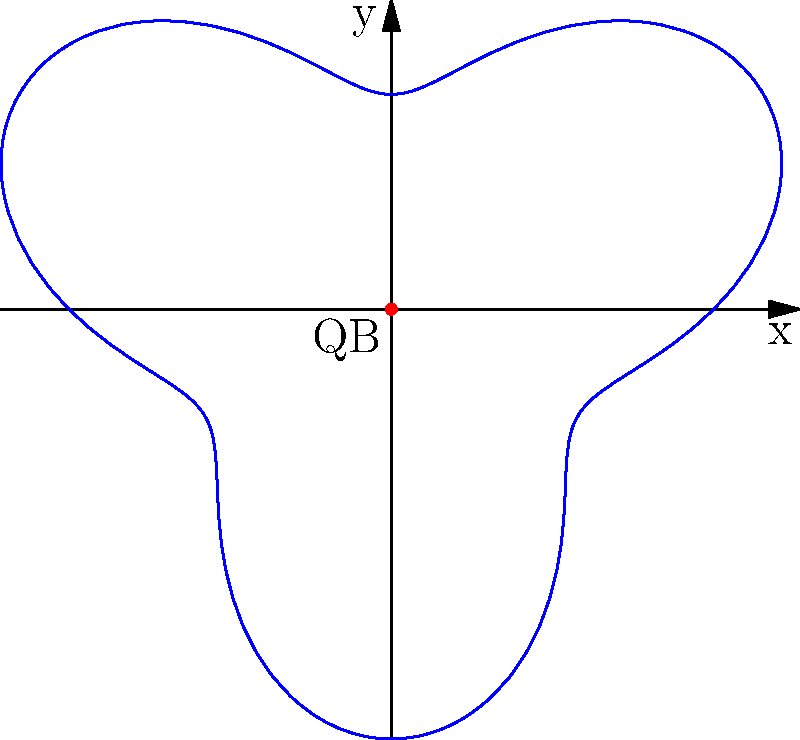As a star wide receiver, you run a complex route that can be modeled using the polar equation $r = 3 + \sin(3\theta)$, where $r$ is in yards. What is the maximum distance you reach from the quarterback (located at the origin) during this route? To find the maximum distance from the quarterback, we need to determine the maximum value of $r$ in the given polar equation.

1) The equation is $r = 3 + \sin(3\theta)$

2) The sine function always oscillates between -1 and 1.

3) When $\sin(3\theta) = 1$, $r$ will be at its maximum.

4) At this point, $r_{max} = 3 + 1 = 4$

5) When $\sin(3\theta) = -1$, $r$ will be at its minimum: $r_{min} = 3 - 1 = 2$

6) Therefore, the route oscillates between 2 and 4 yards from the quarterback.

7) The maximum distance reached is 4 yards.
Answer: 4 yards 